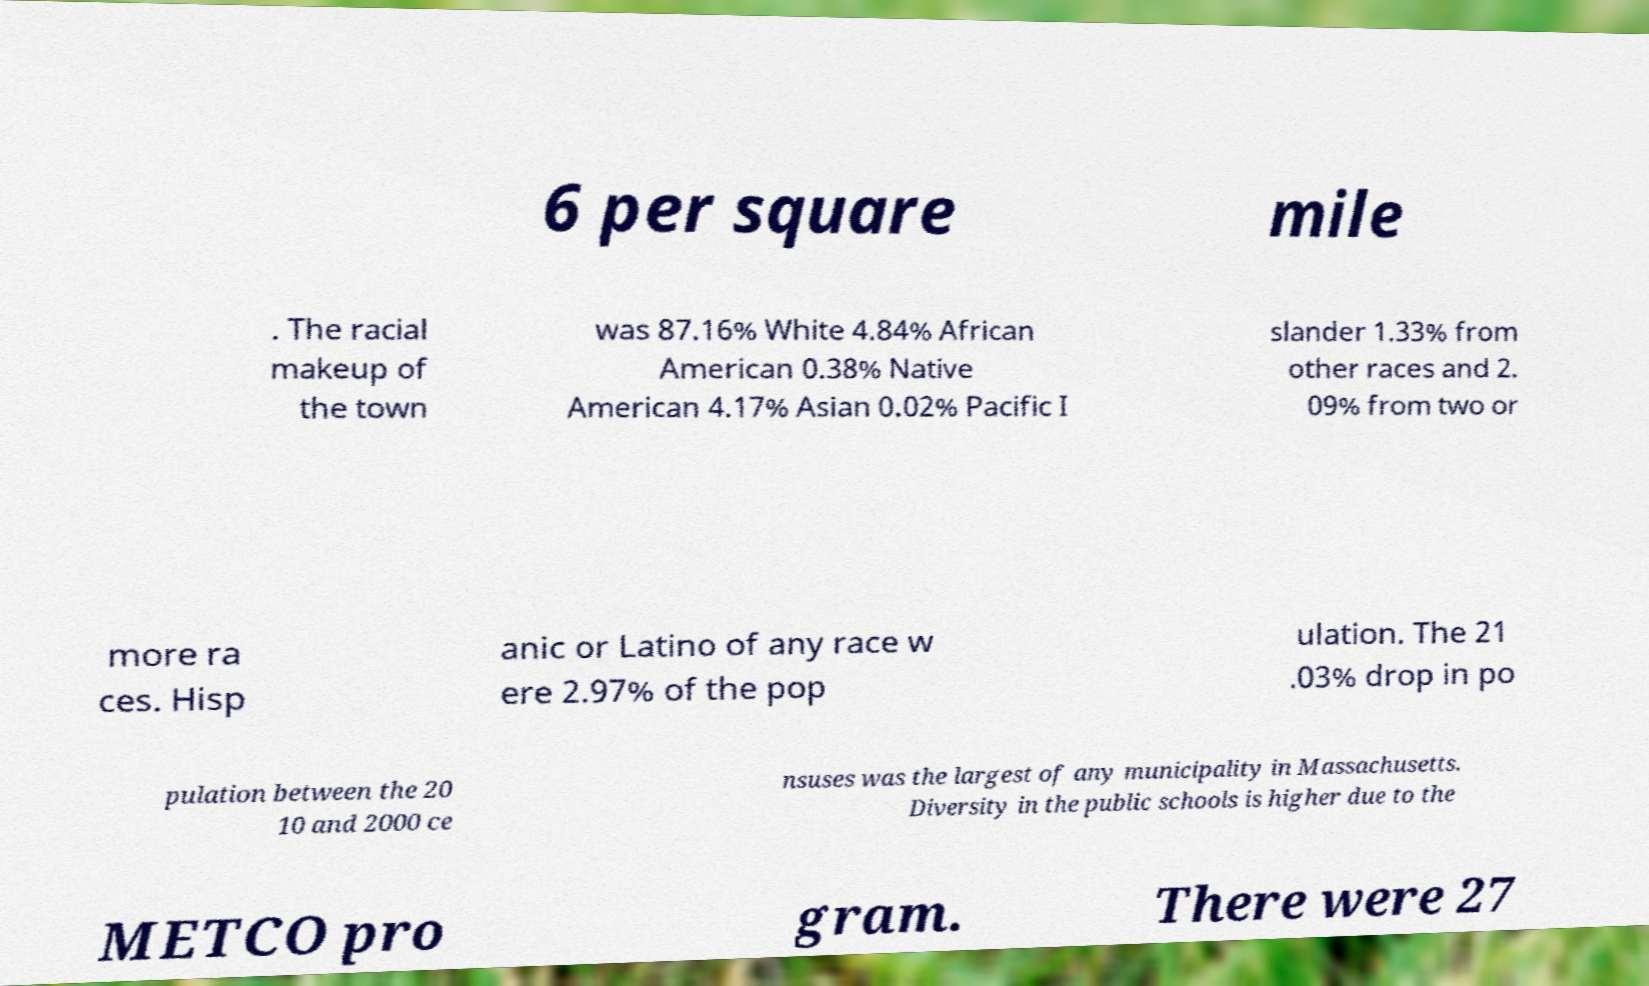Can you accurately transcribe the text from the provided image for me? 6 per square mile . The racial makeup of the town was 87.16% White 4.84% African American 0.38% Native American 4.17% Asian 0.02% Pacific I slander 1.33% from other races and 2. 09% from two or more ra ces. Hisp anic or Latino of any race w ere 2.97% of the pop ulation. The 21 .03% drop in po pulation between the 20 10 and 2000 ce nsuses was the largest of any municipality in Massachusetts. Diversity in the public schools is higher due to the METCO pro gram. There were 27 